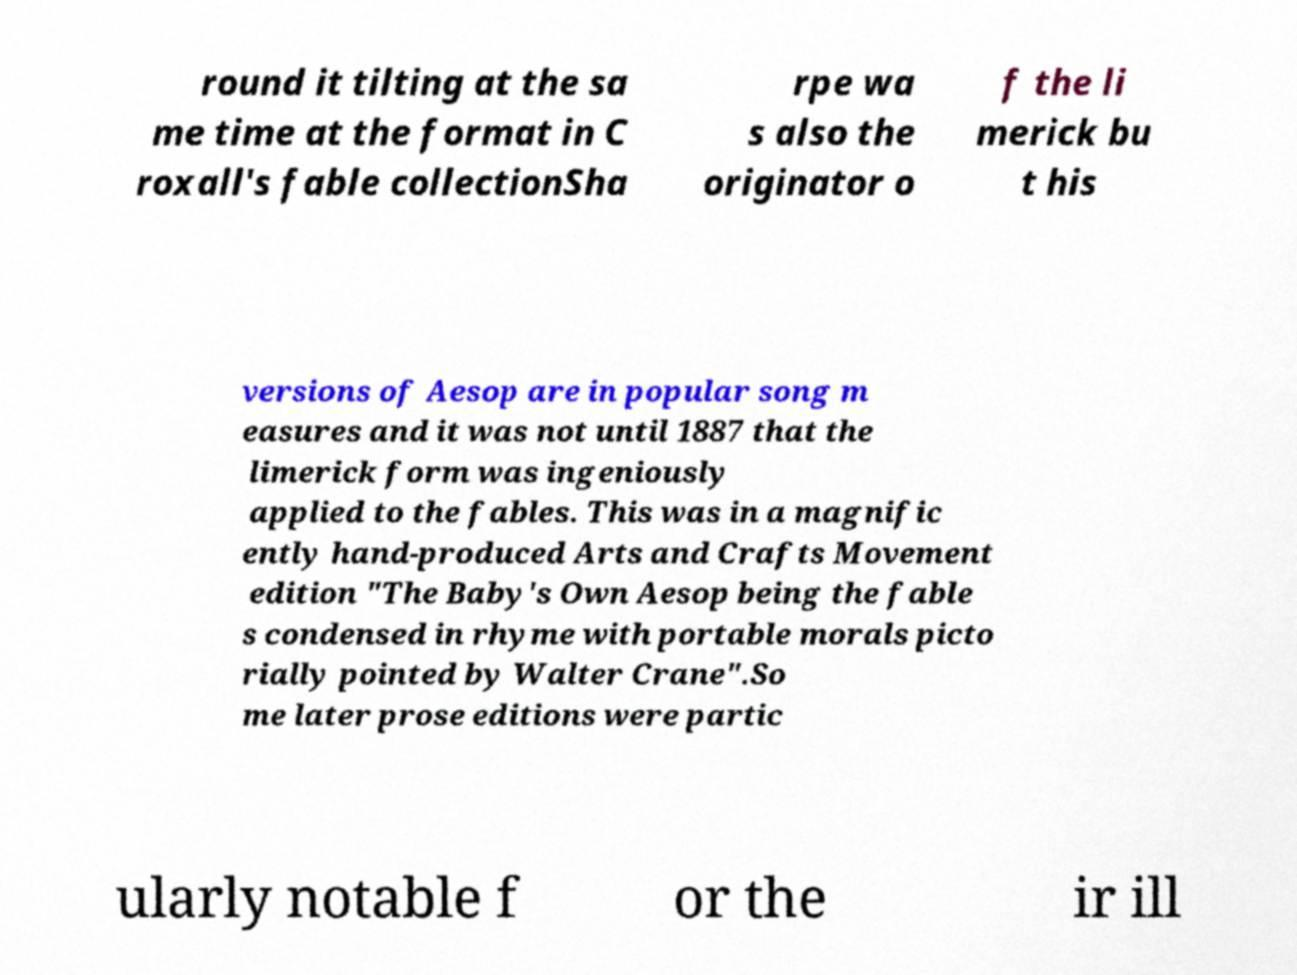Could you extract and type out the text from this image? round it tilting at the sa me time at the format in C roxall's fable collectionSha rpe wa s also the originator o f the li merick bu t his versions of Aesop are in popular song m easures and it was not until 1887 that the limerick form was ingeniously applied to the fables. This was in a magnific ently hand-produced Arts and Crafts Movement edition "The Baby's Own Aesop being the fable s condensed in rhyme with portable morals picto rially pointed by Walter Crane".So me later prose editions were partic ularly notable f or the ir ill 